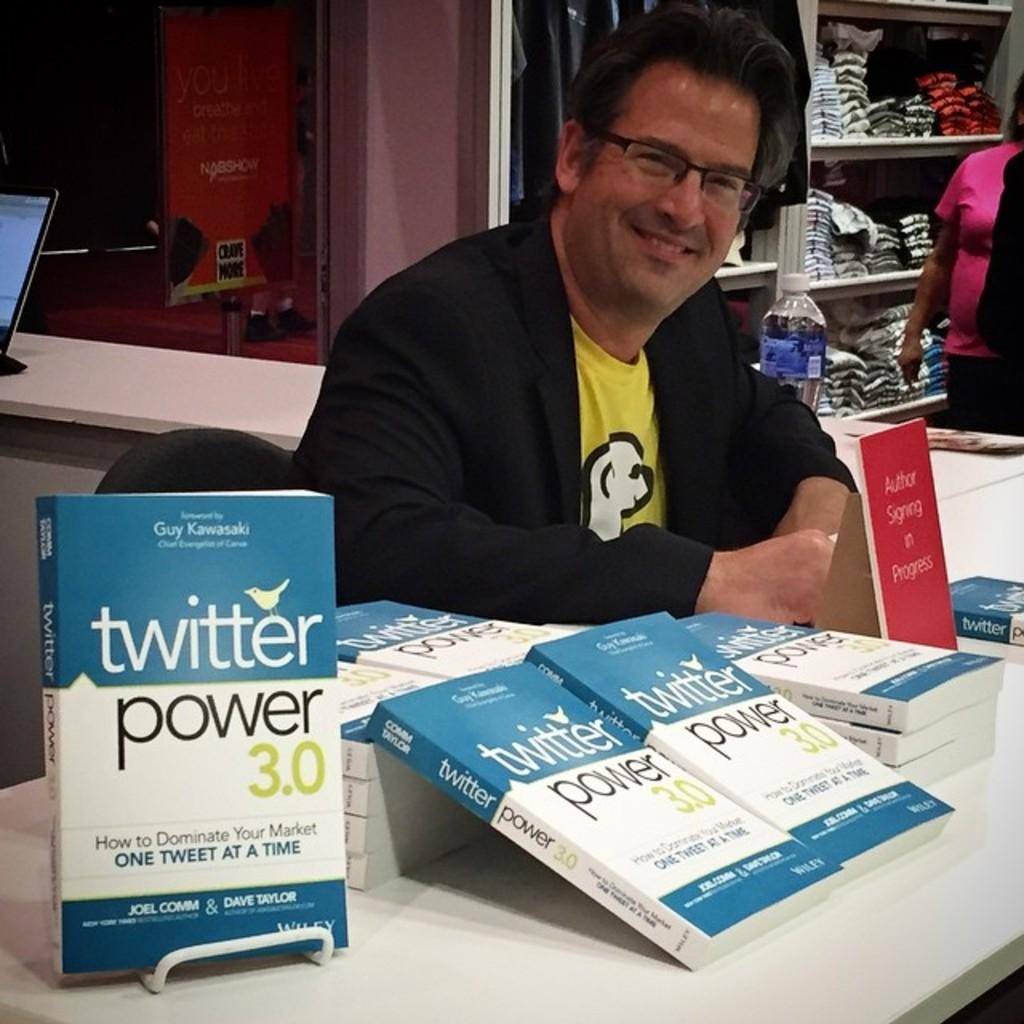<image>
Present a compact description of the photo's key features. a book that is titled Twitter Power sitting on a desk 